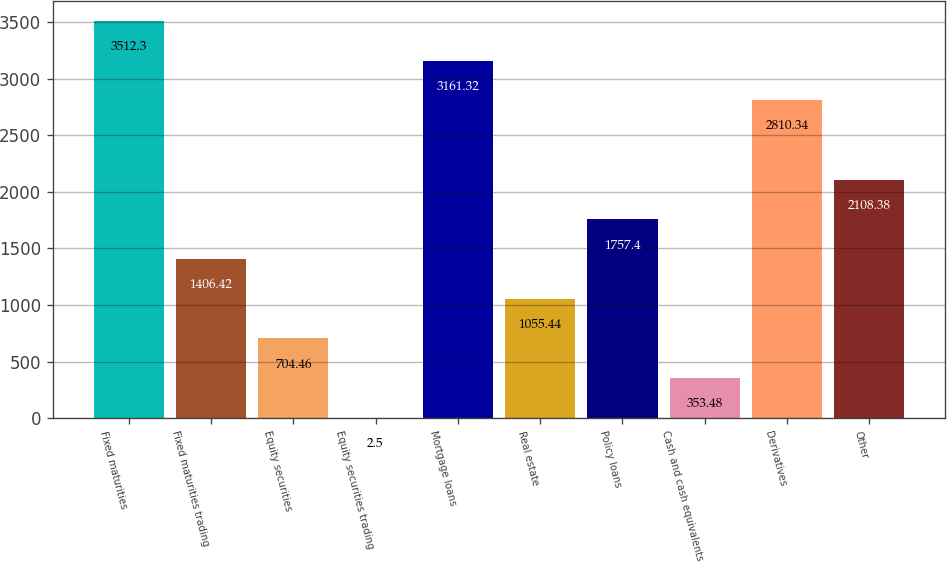Convert chart to OTSL. <chart><loc_0><loc_0><loc_500><loc_500><bar_chart><fcel>Fixed maturities<fcel>Fixed maturities trading<fcel>Equity securities<fcel>Equity securities trading<fcel>Mortgage loans<fcel>Real estate<fcel>Policy loans<fcel>Cash and cash equivalents<fcel>Derivatives<fcel>Other<nl><fcel>3512.3<fcel>1406.42<fcel>704.46<fcel>2.5<fcel>3161.32<fcel>1055.44<fcel>1757.4<fcel>353.48<fcel>2810.34<fcel>2108.38<nl></chart> 